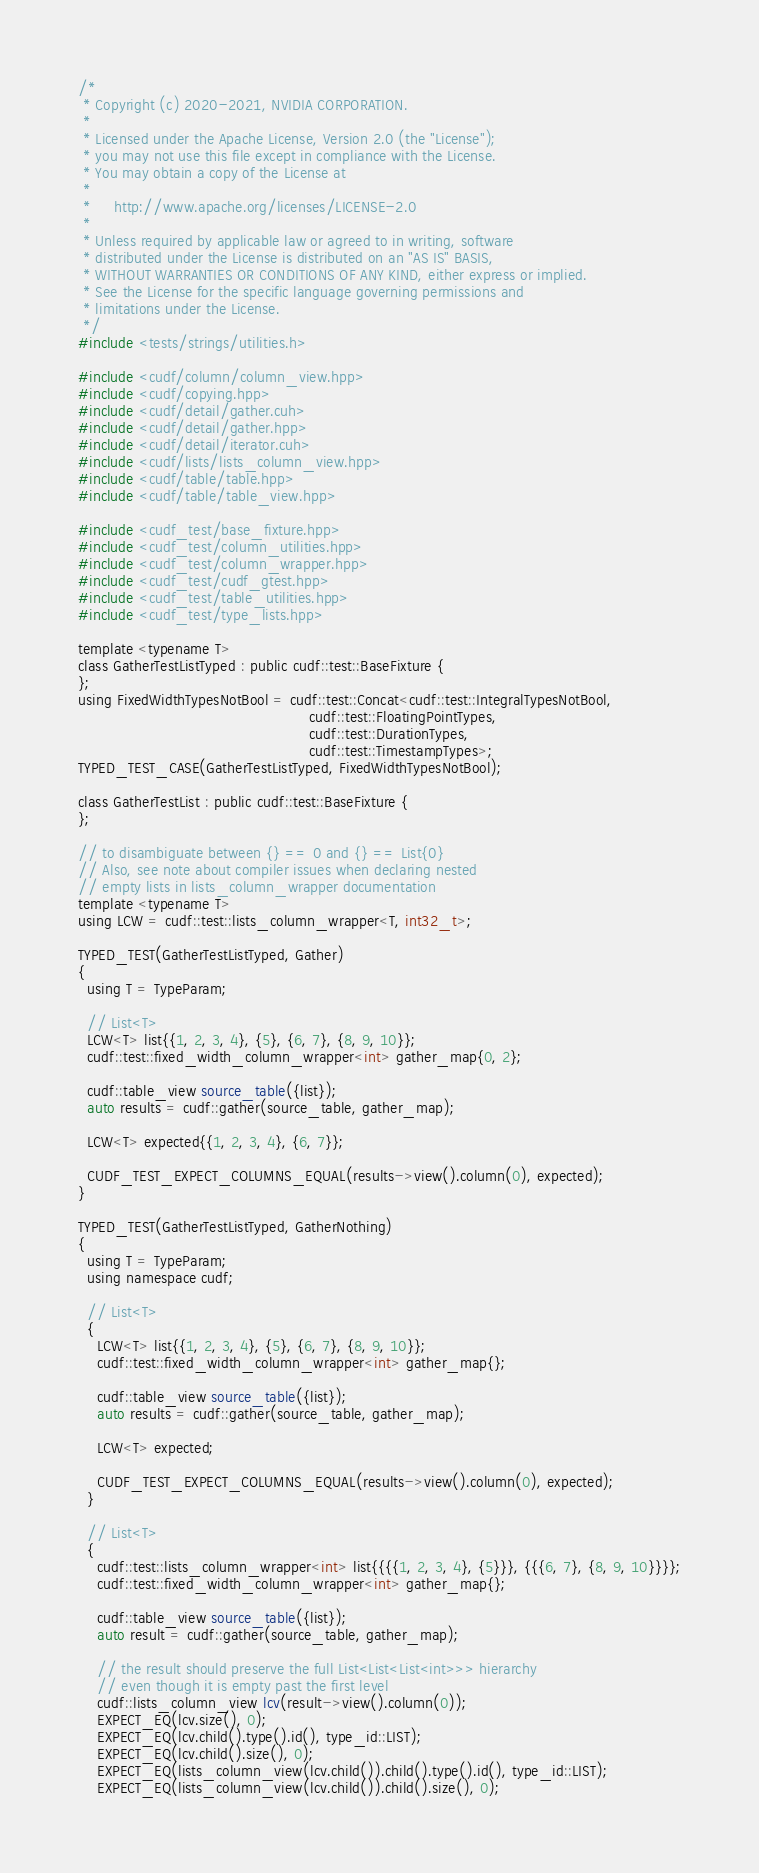Convert code to text. <code><loc_0><loc_0><loc_500><loc_500><_Cuda_>/*
 * Copyright (c) 2020-2021, NVIDIA CORPORATION.
 *
 * Licensed under the Apache License, Version 2.0 (the "License");
 * you may not use this file except in compliance with the License.
 * You may obtain a copy of the License at
 *
 *     http://www.apache.org/licenses/LICENSE-2.0
 *
 * Unless required by applicable law or agreed to in writing, software
 * distributed under the License is distributed on an "AS IS" BASIS,
 * WITHOUT WARRANTIES OR CONDITIONS OF ANY KIND, either express or implied.
 * See the License for the specific language governing permissions and
 * limitations under the License.
 */
#include <tests/strings/utilities.h>

#include <cudf/column/column_view.hpp>
#include <cudf/copying.hpp>
#include <cudf/detail/gather.cuh>
#include <cudf/detail/gather.hpp>
#include <cudf/detail/iterator.cuh>
#include <cudf/lists/lists_column_view.hpp>
#include <cudf/table/table.hpp>
#include <cudf/table/table_view.hpp>

#include <cudf_test/base_fixture.hpp>
#include <cudf_test/column_utilities.hpp>
#include <cudf_test/column_wrapper.hpp>
#include <cudf_test/cudf_gtest.hpp>
#include <cudf_test/table_utilities.hpp>
#include <cudf_test/type_lists.hpp>

template <typename T>
class GatherTestListTyped : public cudf::test::BaseFixture {
};
using FixedWidthTypesNotBool = cudf::test::Concat<cudf::test::IntegralTypesNotBool,
                                                  cudf::test::FloatingPointTypes,
                                                  cudf::test::DurationTypes,
                                                  cudf::test::TimestampTypes>;
TYPED_TEST_CASE(GatherTestListTyped, FixedWidthTypesNotBool);

class GatherTestList : public cudf::test::BaseFixture {
};

// to disambiguate between {} == 0 and {} == List{0}
// Also, see note about compiler issues when declaring nested
// empty lists in lists_column_wrapper documentation
template <typename T>
using LCW = cudf::test::lists_column_wrapper<T, int32_t>;

TYPED_TEST(GatherTestListTyped, Gather)
{
  using T = TypeParam;

  // List<T>
  LCW<T> list{{1, 2, 3, 4}, {5}, {6, 7}, {8, 9, 10}};
  cudf::test::fixed_width_column_wrapper<int> gather_map{0, 2};

  cudf::table_view source_table({list});
  auto results = cudf::gather(source_table, gather_map);

  LCW<T> expected{{1, 2, 3, 4}, {6, 7}};

  CUDF_TEST_EXPECT_COLUMNS_EQUAL(results->view().column(0), expected);
}

TYPED_TEST(GatherTestListTyped, GatherNothing)
{
  using T = TypeParam;
  using namespace cudf;

  // List<T>
  {
    LCW<T> list{{1, 2, 3, 4}, {5}, {6, 7}, {8, 9, 10}};
    cudf::test::fixed_width_column_wrapper<int> gather_map{};

    cudf::table_view source_table({list});
    auto results = cudf::gather(source_table, gather_map);

    LCW<T> expected;

    CUDF_TEST_EXPECT_COLUMNS_EQUAL(results->view().column(0), expected);
  }

  // List<T>
  {
    cudf::test::lists_column_wrapper<int> list{{{{1, 2, 3, 4}, {5}}}, {{{6, 7}, {8, 9, 10}}}};
    cudf::test::fixed_width_column_wrapper<int> gather_map{};

    cudf::table_view source_table({list});
    auto result = cudf::gather(source_table, gather_map);

    // the result should preserve the full List<List<List<int>>> hierarchy
    // even though it is empty past the first level
    cudf::lists_column_view lcv(result->view().column(0));
    EXPECT_EQ(lcv.size(), 0);
    EXPECT_EQ(lcv.child().type().id(), type_id::LIST);
    EXPECT_EQ(lcv.child().size(), 0);
    EXPECT_EQ(lists_column_view(lcv.child()).child().type().id(), type_id::LIST);
    EXPECT_EQ(lists_column_view(lcv.child()).child().size(), 0);</code> 